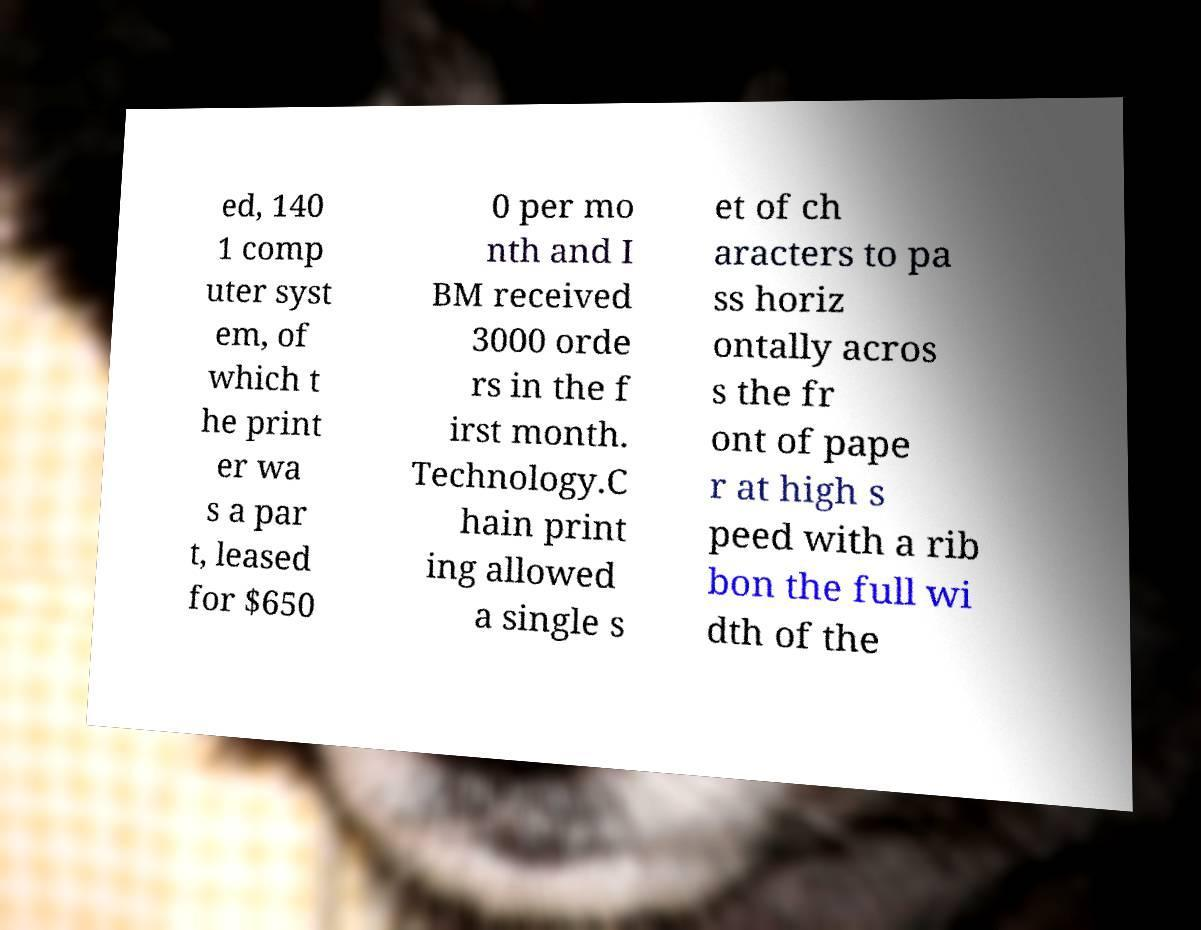There's text embedded in this image that I need extracted. Can you transcribe it verbatim? ed, 140 1 comp uter syst em, of which t he print er wa s a par t, leased for $650 0 per mo nth and I BM received 3000 orde rs in the f irst month. Technology.C hain print ing allowed a single s et of ch aracters to pa ss horiz ontally acros s the fr ont of pape r at high s peed with a rib bon the full wi dth of the 